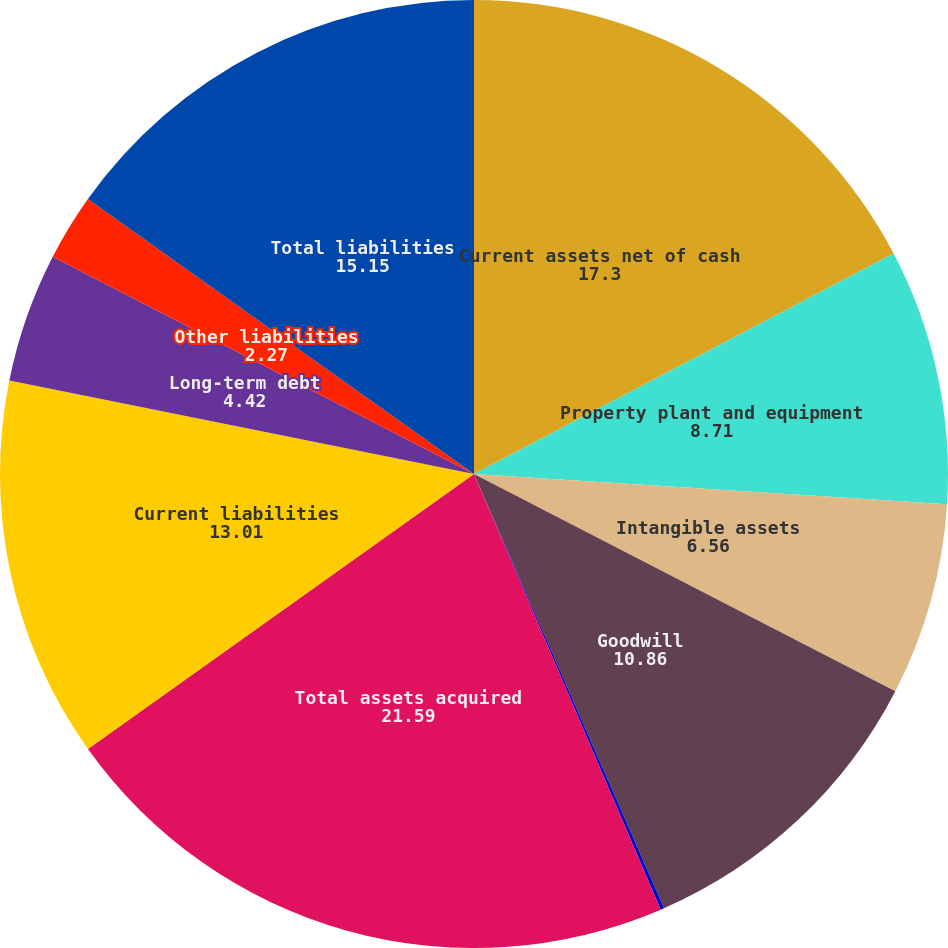Convert chart to OTSL. <chart><loc_0><loc_0><loc_500><loc_500><pie_chart><fcel>Current assets net of cash<fcel>Property plant and equipment<fcel>Intangible assets<fcel>Goodwill<fcel>Other assets<fcel>Total assets acquired<fcel>Current liabilities<fcel>Long-term debt<fcel>Other liabilities<fcel>Total liabilities<nl><fcel>17.3%<fcel>8.71%<fcel>6.56%<fcel>10.86%<fcel>0.12%<fcel>21.59%<fcel>13.01%<fcel>4.42%<fcel>2.27%<fcel>15.15%<nl></chart> 